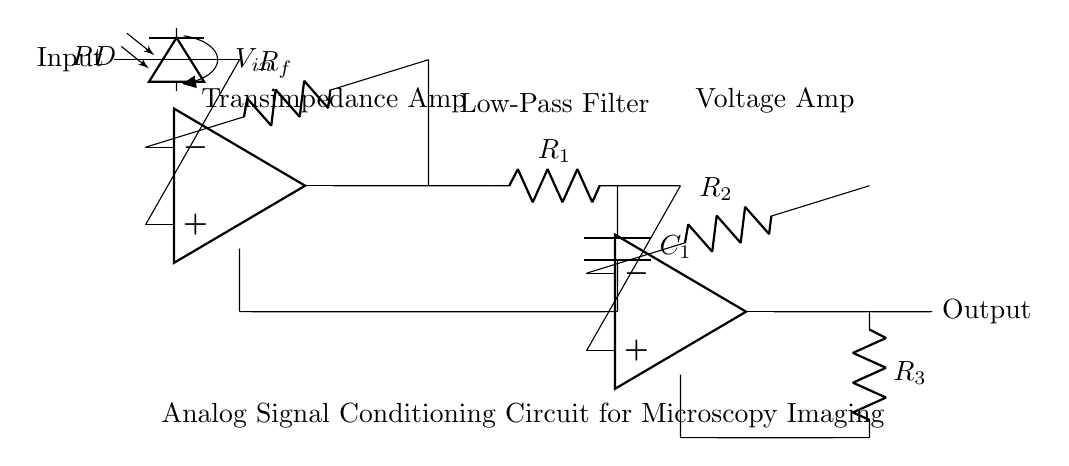What is the type of the first amplifier used in this circuit? The first amplifier in the circuit is a transimpedance amplifier, which converts input current from the photodiode into a voltage output.
Answer: Transimpedance amplifier What is the purpose of the low-pass filter in this circuit? The low-pass filter is used to remove high-frequency noise from the signal, allowing only the desired lower frequency components to pass through.
Answer: To remove high-frequency noise How many resistors are used in the circuit? There are three resistors in the circuit, labeled as R_f, R_1, R_2, and R_3.
Answer: Three resistors Which component is responsible for converting light to an electrical signal? The photodiode is the component responsible for converting the incoming light into an electrical signal that can be further processed.
Answer: Photodiode What is the output of the voltage amplifier measured at? The output of the voltage amplifier is measured at the terminal connected to R_3, which serves as the output stage of the circuit.
Answer: Terminal connected to R_3 What happens to the output signal after it passes through the transimpedance amplifier? The output signal becomes a voltage signal proportional to the input current from the photodiode, which is then conditioned for further processing.
Answer: Becomes voltage proportional to input current 